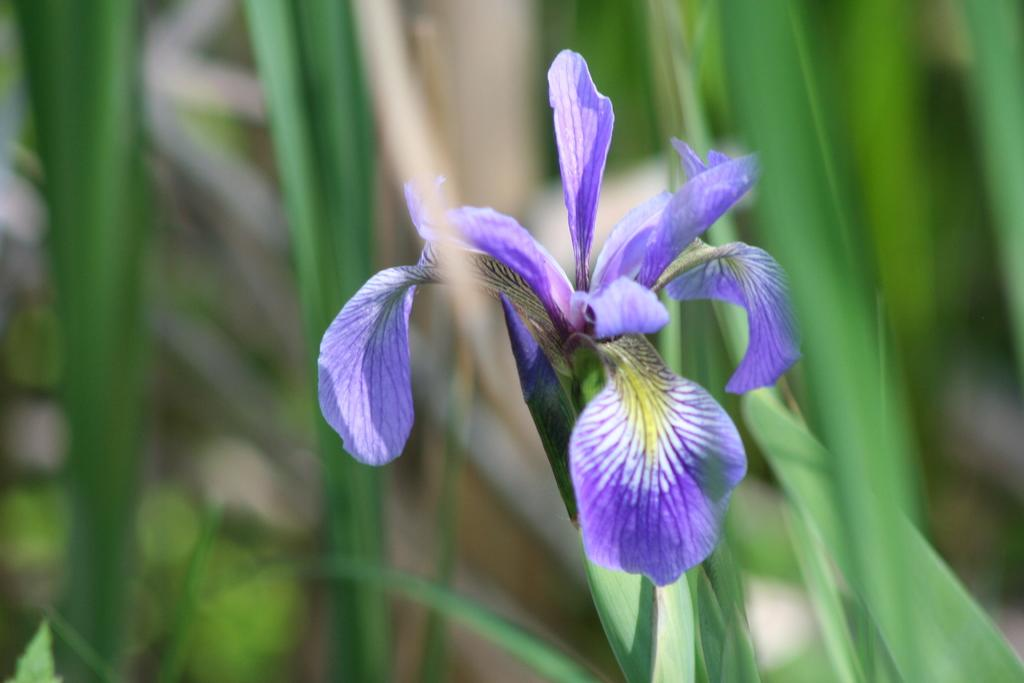What type of plant can be seen in the image? There is a flower plant in the image. Can you tell me how many girls are having a discussion near the sea in the image? There is no sea, girl, or discussion present in the image; it only features a flower plant. 